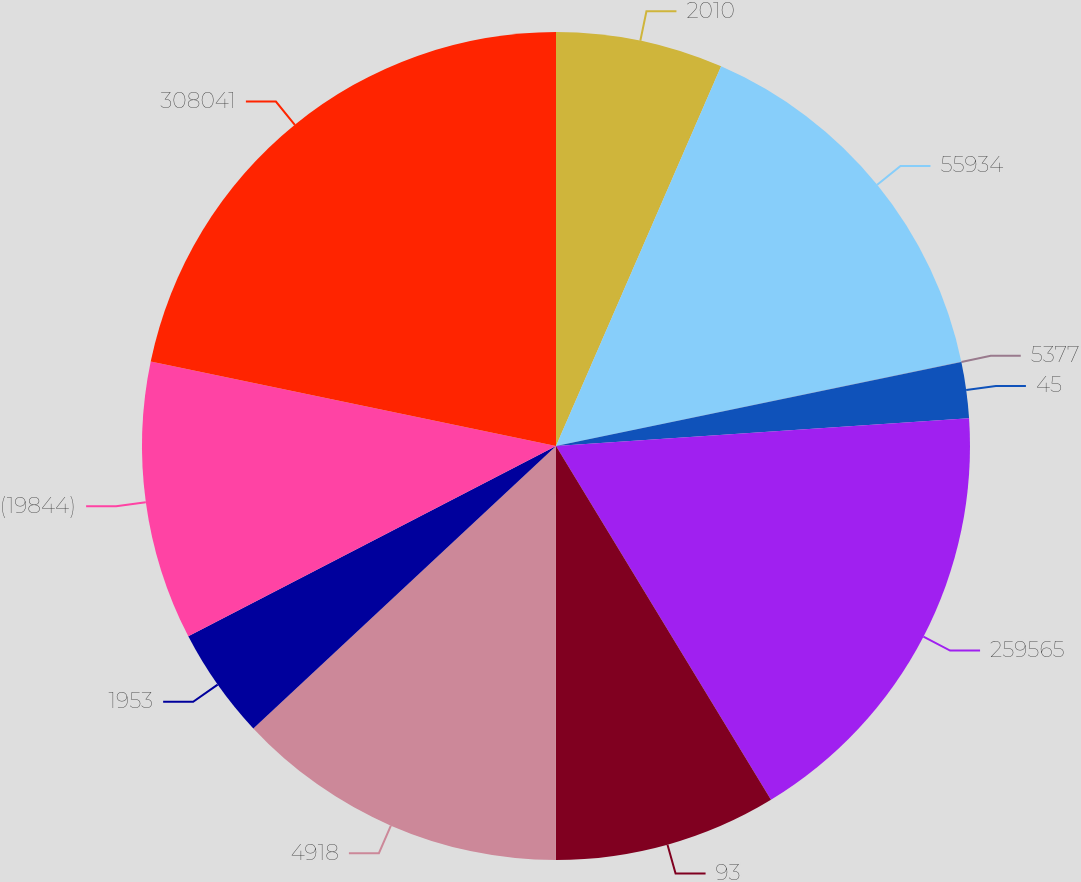Convert chart. <chart><loc_0><loc_0><loc_500><loc_500><pie_chart><fcel>2010<fcel>55934<fcel>5377<fcel>45<fcel>259565<fcel>93<fcel>4918<fcel>1953<fcel>(19844)<fcel>308041<nl><fcel>6.53%<fcel>15.21%<fcel>0.01%<fcel>2.18%<fcel>17.38%<fcel>8.7%<fcel>13.04%<fcel>4.35%<fcel>10.87%<fcel>21.73%<nl></chart> 